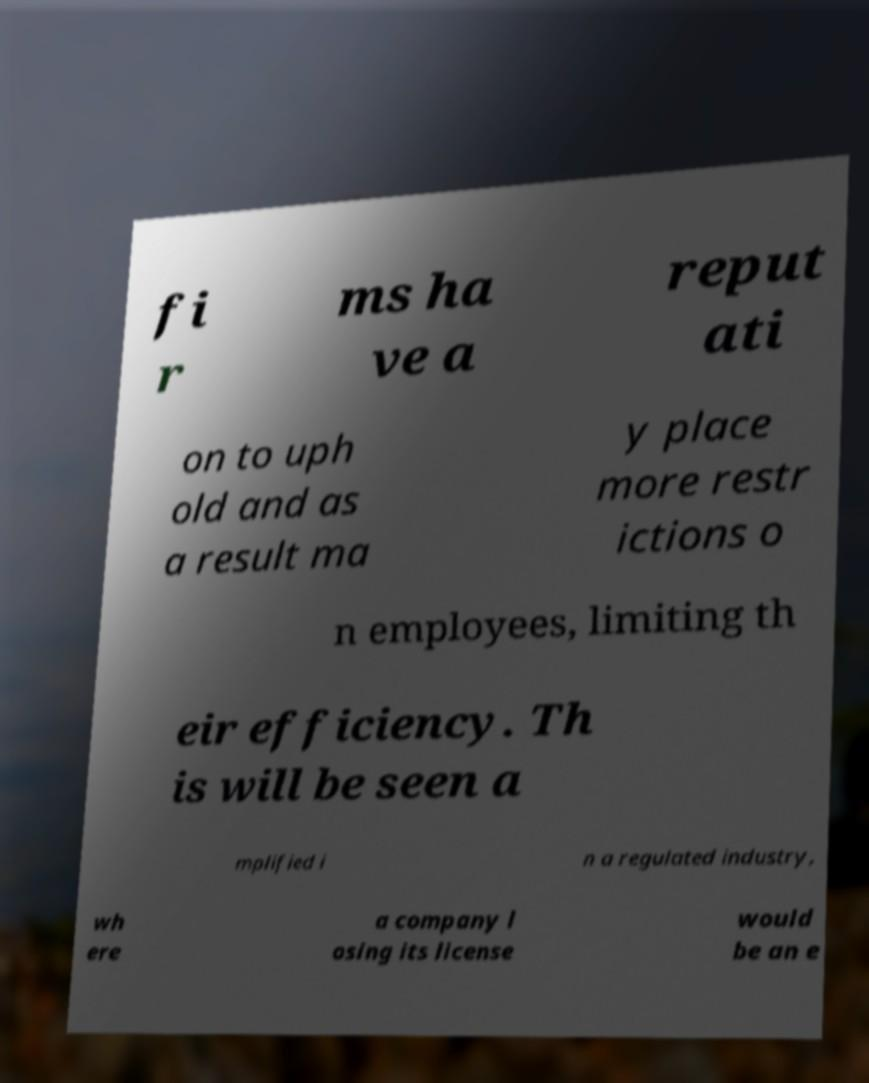Could you assist in decoding the text presented in this image and type it out clearly? fi r ms ha ve a reput ati on to uph old and as a result ma y place more restr ictions o n employees, limiting th eir efficiency. Th is will be seen a mplified i n a regulated industry, wh ere a company l osing its license would be an e 